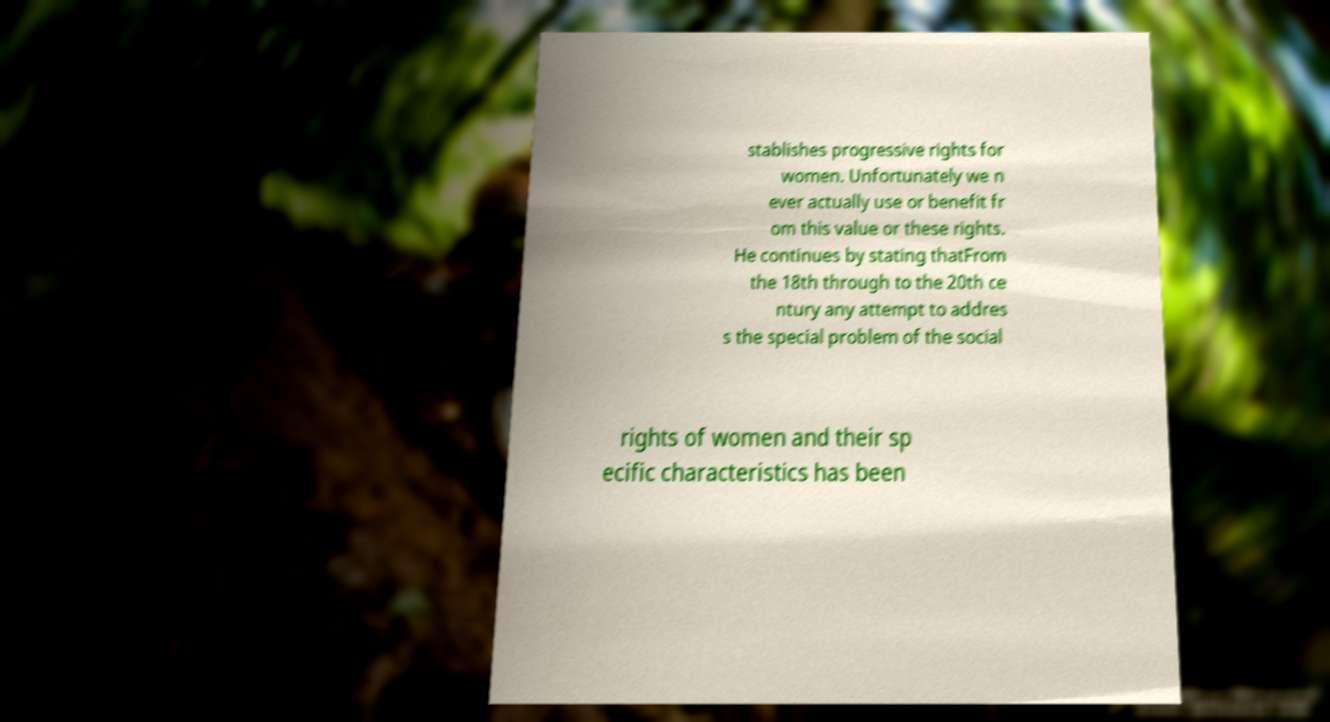Could you extract and type out the text from this image? stablishes progressive rights for women. Unfortunately we n ever actually use or benefit fr om this value or these rights. He continues by stating thatFrom the 18th through to the 20th ce ntury any attempt to addres s the special problem of the social rights of women and their sp ecific characteristics has been 